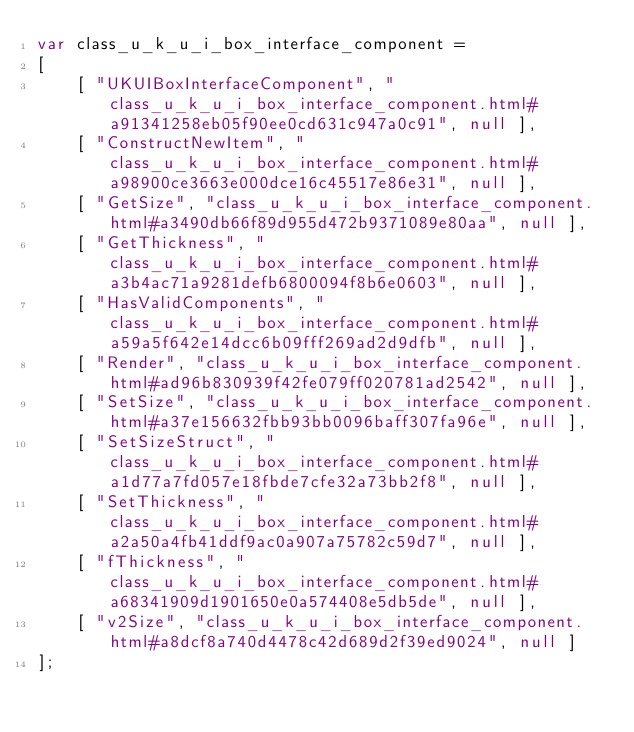Convert code to text. <code><loc_0><loc_0><loc_500><loc_500><_JavaScript_>var class_u_k_u_i_box_interface_component =
[
    [ "UKUIBoxInterfaceComponent", "class_u_k_u_i_box_interface_component.html#a91341258eb05f90ee0cd631c947a0c91", null ],
    [ "ConstructNewItem", "class_u_k_u_i_box_interface_component.html#a98900ce3663e000dce16c45517e86e31", null ],
    [ "GetSize", "class_u_k_u_i_box_interface_component.html#a3490db66f89d955d472b9371089e80aa", null ],
    [ "GetThickness", "class_u_k_u_i_box_interface_component.html#a3b4ac71a9281defb6800094f8b6e0603", null ],
    [ "HasValidComponents", "class_u_k_u_i_box_interface_component.html#a59a5f642e14dcc6b09fff269ad2d9dfb", null ],
    [ "Render", "class_u_k_u_i_box_interface_component.html#ad96b830939f42fe079ff020781ad2542", null ],
    [ "SetSize", "class_u_k_u_i_box_interface_component.html#a37e156632fbb93bb0096baff307fa96e", null ],
    [ "SetSizeStruct", "class_u_k_u_i_box_interface_component.html#a1d77a7fd057e18fbde7cfe32a73bb2f8", null ],
    [ "SetThickness", "class_u_k_u_i_box_interface_component.html#a2a50a4fb41ddf9ac0a907a75782c59d7", null ],
    [ "fThickness", "class_u_k_u_i_box_interface_component.html#a68341909d1901650e0a574408e5db5de", null ],
    [ "v2Size", "class_u_k_u_i_box_interface_component.html#a8dcf8a740d4478c42d689d2f39ed9024", null ]
];</code> 